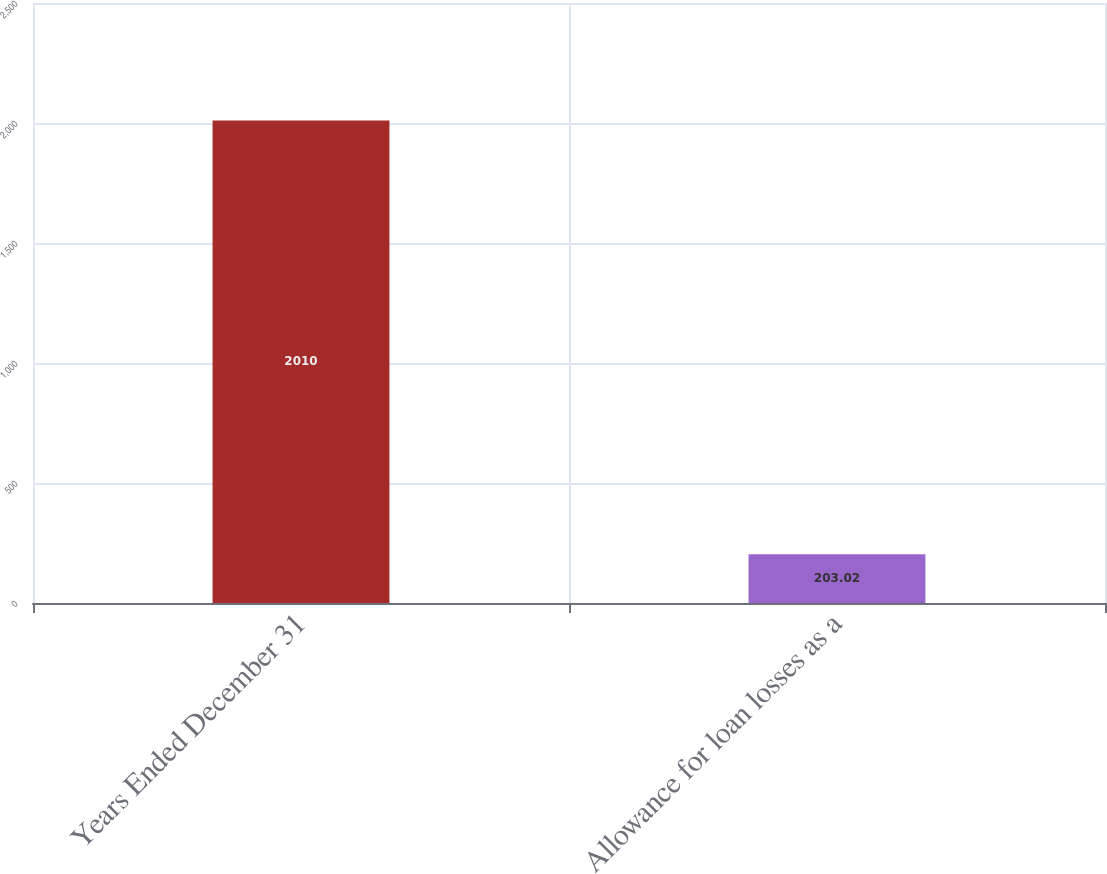<chart> <loc_0><loc_0><loc_500><loc_500><bar_chart><fcel>Years Ended December 31<fcel>Allowance for loan losses as a<nl><fcel>2010<fcel>203.02<nl></chart> 